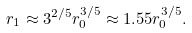Convert formula to latex. <formula><loc_0><loc_0><loc_500><loc_500>r _ { 1 } \approx 3 ^ { 2 / 5 } r _ { 0 } ^ { 3 / 5 } \approx 1 . 5 5 r _ { 0 } ^ { 3 / 5 } .</formula> 